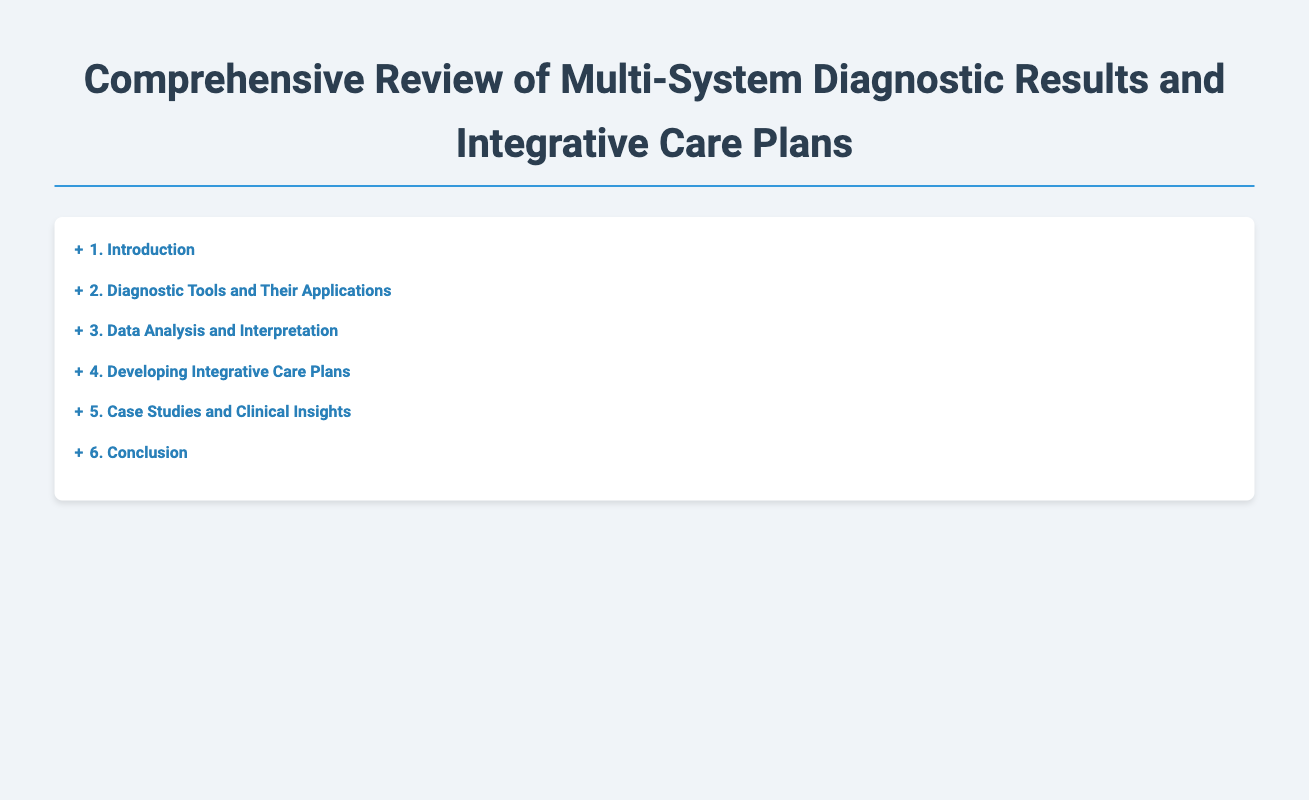What is the title of the document? The title of the document is stated prominently at the top, which outlines its focus.
Answer: Comprehensive Review of Multi-System Diagnostic Results and Integrative Care Plans How many main sections are in the Table of Contents? The document has a clear structure with defined main sections, indicated by the numbers.
Answer: 6 What is the first subsection covered under Diagnostic Tools? The subsections provide detailed insights into various diagnostic tools categorized by system.
Answer: Echocardiography What is emphasized as important in geriatrics in the Introduction? The Introduction highlights a crucial aspect of elderly care that is discussed in the first section.
Answer: Importance of Integrative Care in Geriatrics Which system’s diagnostic tools include Arterial Blood Gas Analysis? This requires understanding the categorization of diagnostic tools across systems presented in the document.
Answer: Respiratory System What does section 4 focus on? Section 4 is targeted towards developing strategic care plans for patients, as indicated in the title.
Answer: Developing Integrative Care Plans Which case study is included in the document? The document includes specific case studies that help illustrate the clinical applications discussed.
Answer: Case Study: Managing Multi-Morbidities What does the Conclusion summarize? The Conclusion section provides a wrap-up of the key points discussed in the preceding sections of the document.
Answer: Summary of Key Concepts 